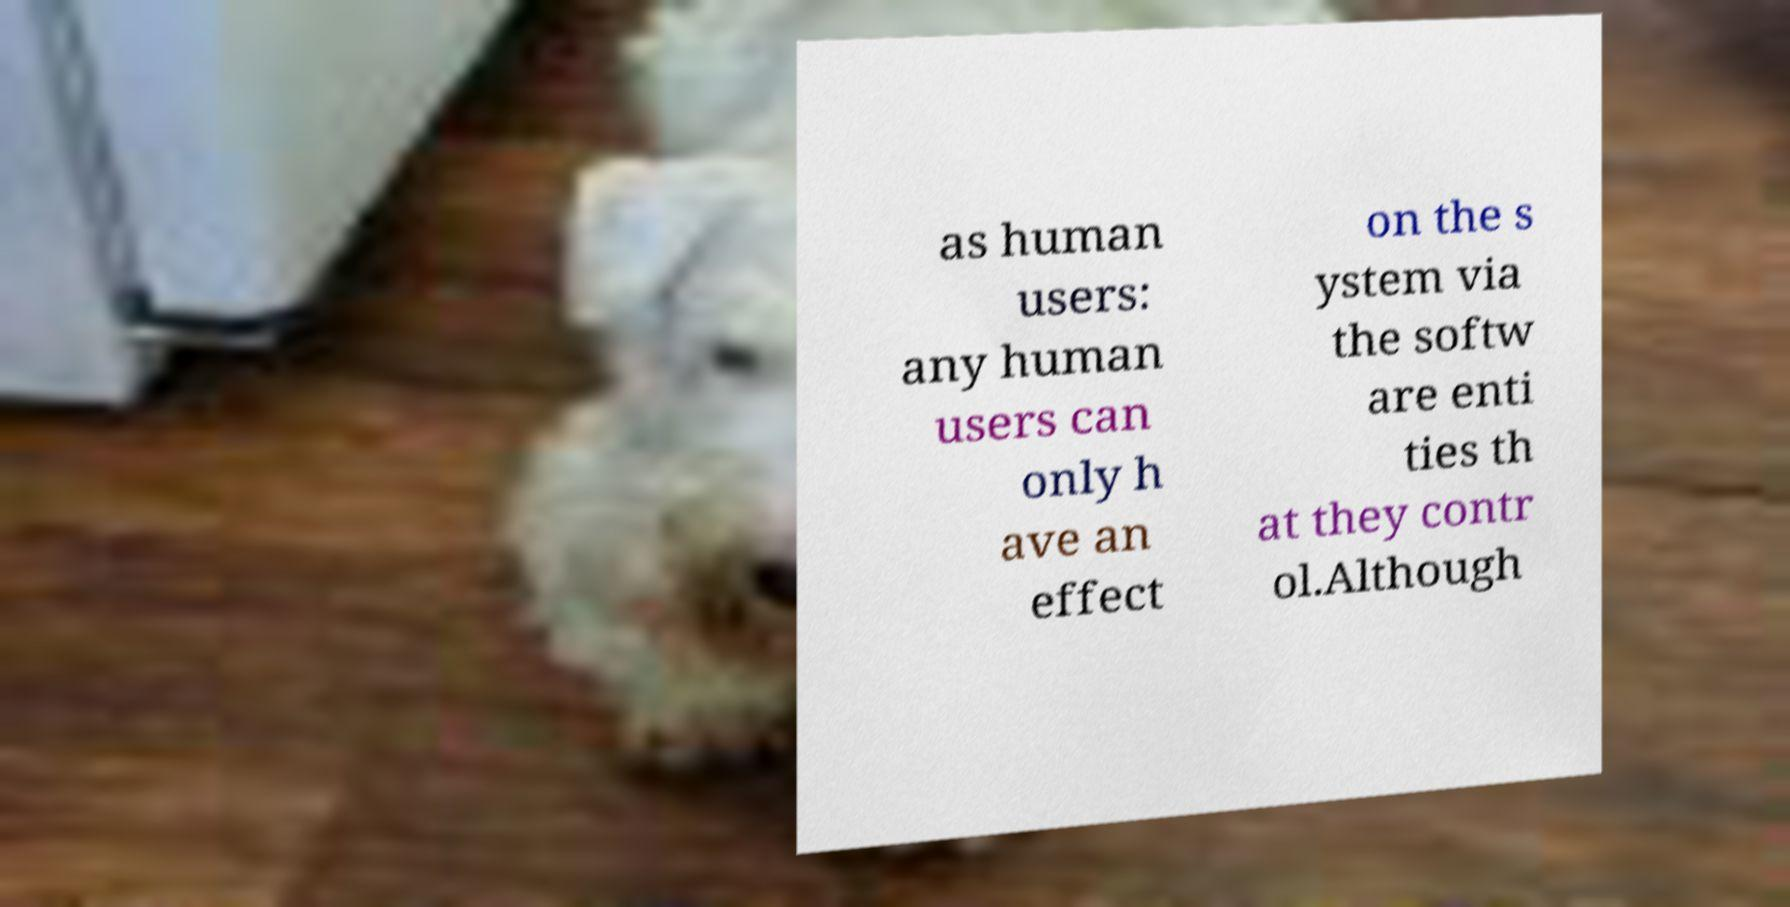Could you assist in decoding the text presented in this image and type it out clearly? as human users: any human users can only h ave an effect on the s ystem via the softw are enti ties th at they contr ol.Although 